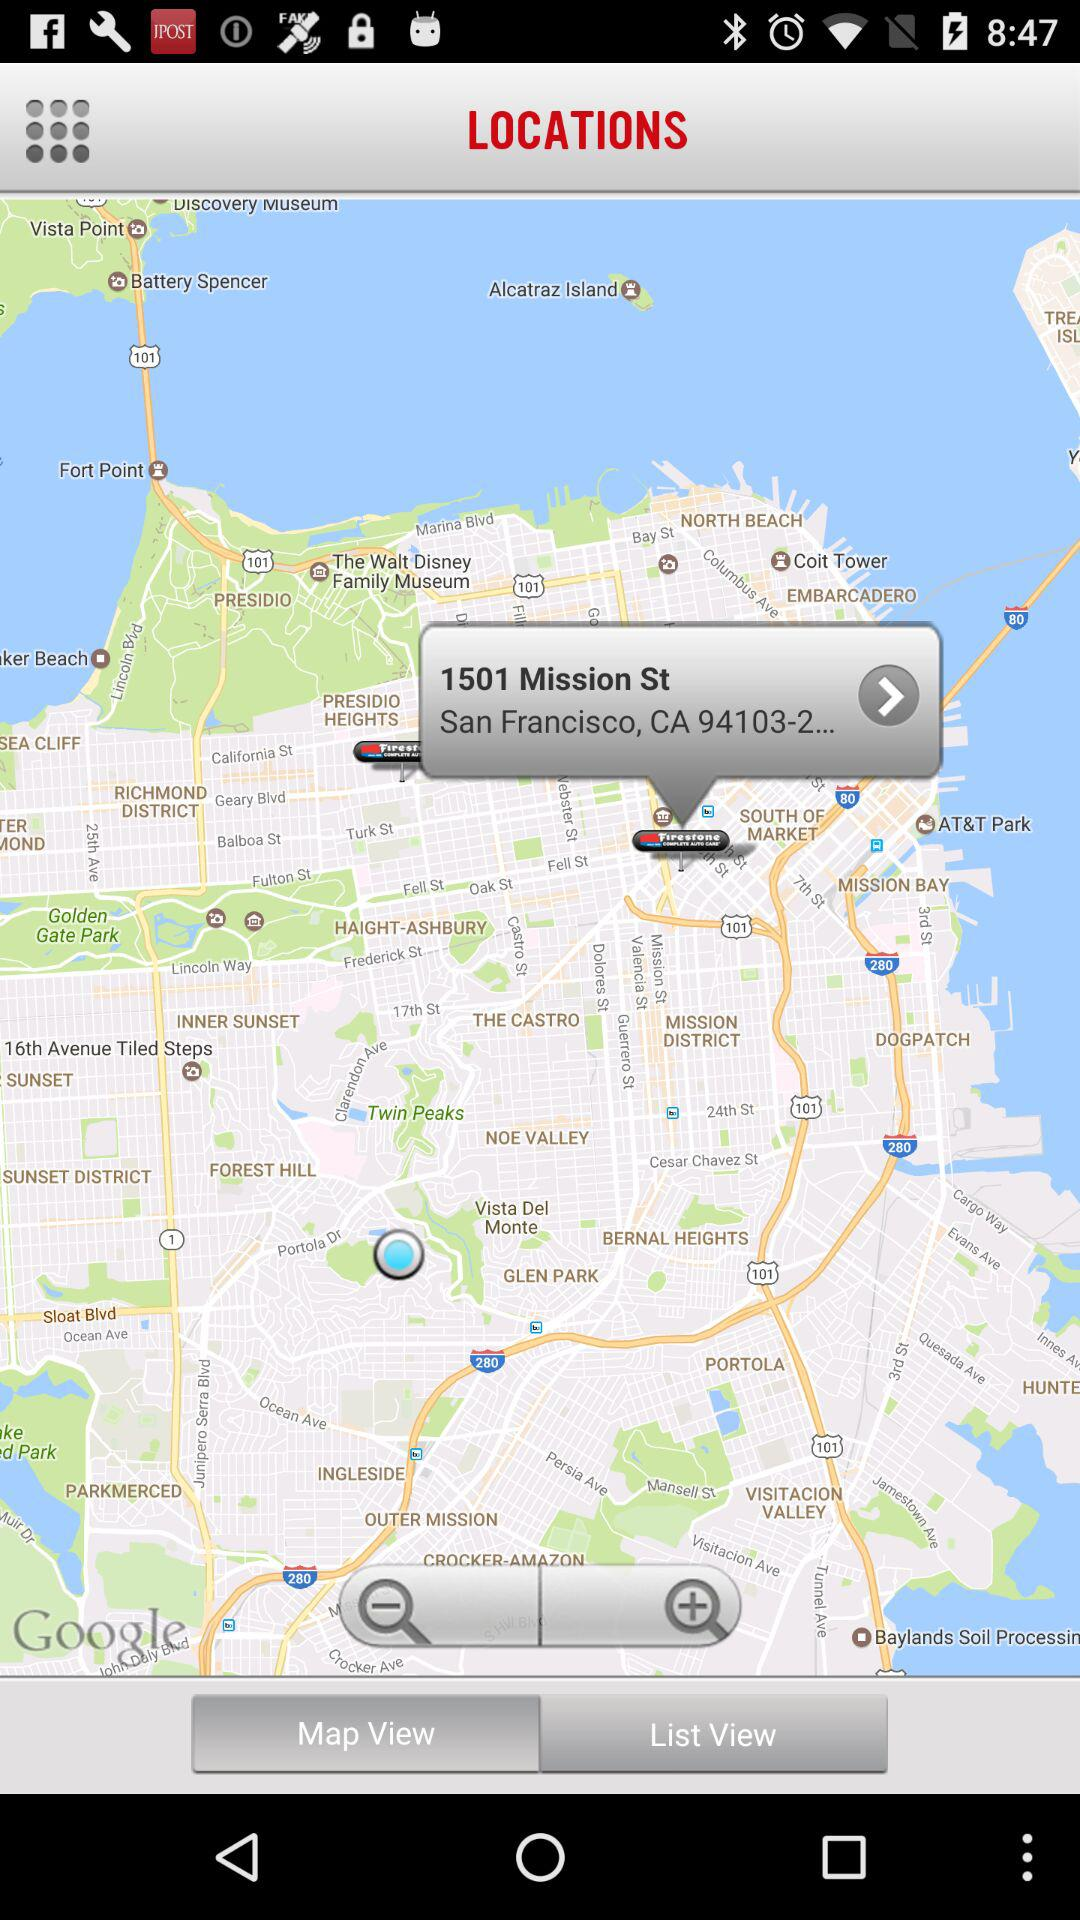Which tab is selected? The selected tab is "Map View". 